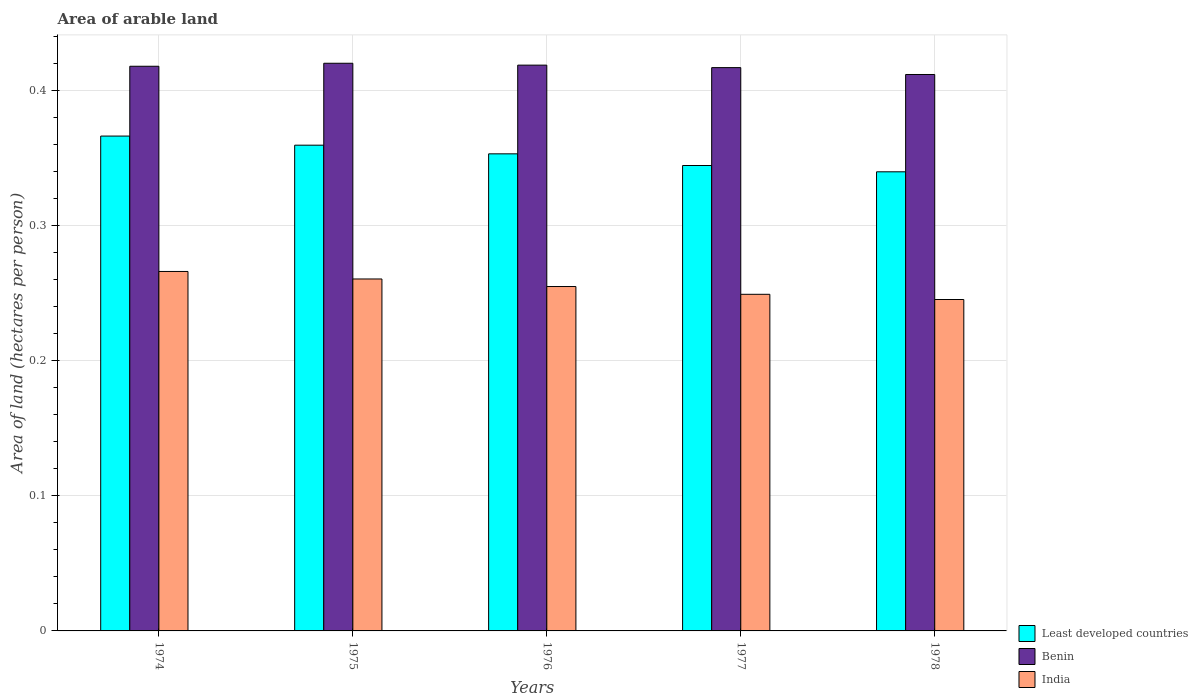How many groups of bars are there?
Make the answer very short. 5. How many bars are there on the 2nd tick from the left?
Give a very brief answer. 3. How many bars are there on the 3rd tick from the right?
Your answer should be compact. 3. What is the label of the 2nd group of bars from the left?
Make the answer very short. 1975. In how many cases, is the number of bars for a given year not equal to the number of legend labels?
Provide a short and direct response. 0. What is the total arable land in Least developed countries in 1974?
Offer a very short reply. 0.37. Across all years, what is the maximum total arable land in India?
Keep it short and to the point. 0.27. Across all years, what is the minimum total arable land in India?
Make the answer very short. 0.25. In which year was the total arable land in Benin maximum?
Keep it short and to the point. 1975. In which year was the total arable land in Least developed countries minimum?
Provide a succinct answer. 1978. What is the total total arable land in India in the graph?
Offer a terse response. 1.28. What is the difference between the total arable land in Benin in 1975 and that in 1976?
Your response must be concise. 0. What is the difference between the total arable land in India in 1975 and the total arable land in Benin in 1976?
Offer a terse response. -0.16. What is the average total arable land in India per year?
Your answer should be compact. 0.26. In the year 1974, what is the difference between the total arable land in India and total arable land in Least developed countries?
Keep it short and to the point. -0.1. In how many years, is the total arable land in India greater than 0.26 hectares per person?
Give a very brief answer. 2. What is the ratio of the total arable land in Benin in 1976 to that in 1977?
Provide a short and direct response. 1. Is the total arable land in Benin in 1974 less than that in 1977?
Keep it short and to the point. No. Is the difference between the total arable land in India in 1974 and 1976 greater than the difference between the total arable land in Least developed countries in 1974 and 1976?
Provide a short and direct response. No. What is the difference between the highest and the second highest total arable land in Benin?
Ensure brevity in your answer.  0. What is the difference between the highest and the lowest total arable land in Least developed countries?
Provide a succinct answer. 0.03. What does the 1st bar from the left in 1975 represents?
Your answer should be very brief. Least developed countries. What does the 2nd bar from the right in 1975 represents?
Offer a very short reply. Benin. Is it the case that in every year, the sum of the total arable land in Least developed countries and total arable land in Benin is greater than the total arable land in India?
Offer a terse response. Yes. How many bars are there?
Offer a terse response. 15. Are all the bars in the graph horizontal?
Your answer should be very brief. No. How many years are there in the graph?
Provide a short and direct response. 5. Does the graph contain any zero values?
Offer a terse response. No. Where does the legend appear in the graph?
Your answer should be compact. Bottom right. How many legend labels are there?
Your answer should be very brief. 3. How are the legend labels stacked?
Your answer should be compact. Vertical. What is the title of the graph?
Ensure brevity in your answer.  Area of arable land. What is the label or title of the X-axis?
Offer a terse response. Years. What is the label or title of the Y-axis?
Your response must be concise. Area of land (hectares per person). What is the Area of land (hectares per person) in Least developed countries in 1974?
Make the answer very short. 0.37. What is the Area of land (hectares per person) of Benin in 1974?
Offer a very short reply. 0.42. What is the Area of land (hectares per person) of India in 1974?
Ensure brevity in your answer.  0.27. What is the Area of land (hectares per person) in Least developed countries in 1975?
Give a very brief answer. 0.36. What is the Area of land (hectares per person) in Benin in 1975?
Provide a short and direct response. 0.42. What is the Area of land (hectares per person) of India in 1975?
Your answer should be compact. 0.26. What is the Area of land (hectares per person) of Least developed countries in 1976?
Make the answer very short. 0.35. What is the Area of land (hectares per person) in Benin in 1976?
Offer a very short reply. 0.42. What is the Area of land (hectares per person) in India in 1976?
Provide a succinct answer. 0.25. What is the Area of land (hectares per person) of Least developed countries in 1977?
Your answer should be compact. 0.34. What is the Area of land (hectares per person) in Benin in 1977?
Your answer should be very brief. 0.42. What is the Area of land (hectares per person) in India in 1977?
Give a very brief answer. 0.25. What is the Area of land (hectares per person) in Least developed countries in 1978?
Provide a succinct answer. 0.34. What is the Area of land (hectares per person) of Benin in 1978?
Provide a succinct answer. 0.41. What is the Area of land (hectares per person) in India in 1978?
Ensure brevity in your answer.  0.25. Across all years, what is the maximum Area of land (hectares per person) of Least developed countries?
Give a very brief answer. 0.37. Across all years, what is the maximum Area of land (hectares per person) of Benin?
Offer a very short reply. 0.42. Across all years, what is the maximum Area of land (hectares per person) of India?
Provide a short and direct response. 0.27. Across all years, what is the minimum Area of land (hectares per person) of Least developed countries?
Your answer should be very brief. 0.34. Across all years, what is the minimum Area of land (hectares per person) of Benin?
Offer a very short reply. 0.41. Across all years, what is the minimum Area of land (hectares per person) of India?
Keep it short and to the point. 0.25. What is the total Area of land (hectares per person) of Least developed countries in the graph?
Your answer should be compact. 1.76. What is the total Area of land (hectares per person) in Benin in the graph?
Offer a terse response. 2.08. What is the total Area of land (hectares per person) in India in the graph?
Provide a succinct answer. 1.27. What is the difference between the Area of land (hectares per person) of Least developed countries in 1974 and that in 1975?
Make the answer very short. 0.01. What is the difference between the Area of land (hectares per person) of Benin in 1974 and that in 1975?
Your answer should be compact. -0. What is the difference between the Area of land (hectares per person) in India in 1974 and that in 1975?
Offer a terse response. 0.01. What is the difference between the Area of land (hectares per person) of Least developed countries in 1974 and that in 1976?
Make the answer very short. 0.01. What is the difference between the Area of land (hectares per person) in Benin in 1974 and that in 1976?
Offer a terse response. -0. What is the difference between the Area of land (hectares per person) of India in 1974 and that in 1976?
Provide a short and direct response. 0.01. What is the difference between the Area of land (hectares per person) in Least developed countries in 1974 and that in 1977?
Ensure brevity in your answer.  0.02. What is the difference between the Area of land (hectares per person) of Benin in 1974 and that in 1977?
Your response must be concise. 0. What is the difference between the Area of land (hectares per person) in India in 1974 and that in 1977?
Keep it short and to the point. 0.02. What is the difference between the Area of land (hectares per person) in Least developed countries in 1974 and that in 1978?
Your answer should be very brief. 0.03. What is the difference between the Area of land (hectares per person) in Benin in 1974 and that in 1978?
Your answer should be compact. 0.01. What is the difference between the Area of land (hectares per person) in India in 1974 and that in 1978?
Offer a very short reply. 0.02. What is the difference between the Area of land (hectares per person) in Least developed countries in 1975 and that in 1976?
Ensure brevity in your answer.  0.01. What is the difference between the Area of land (hectares per person) of Benin in 1975 and that in 1976?
Provide a short and direct response. 0. What is the difference between the Area of land (hectares per person) of India in 1975 and that in 1976?
Your response must be concise. 0.01. What is the difference between the Area of land (hectares per person) of Least developed countries in 1975 and that in 1977?
Provide a succinct answer. 0.01. What is the difference between the Area of land (hectares per person) in Benin in 1975 and that in 1977?
Provide a succinct answer. 0. What is the difference between the Area of land (hectares per person) of India in 1975 and that in 1977?
Offer a terse response. 0.01. What is the difference between the Area of land (hectares per person) in Least developed countries in 1975 and that in 1978?
Your answer should be very brief. 0.02. What is the difference between the Area of land (hectares per person) of Benin in 1975 and that in 1978?
Offer a terse response. 0.01. What is the difference between the Area of land (hectares per person) of India in 1975 and that in 1978?
Provide a short and direct response. 0.02. What is the difference between the Area of land (hectares per person) of Least developed countries in 1976 and that in 1977?
Your answer should be very brief. 0.01. What is the difference between the Area of land (hectares per person) in Benin in 1976 and that in 1977?
Your response must be concise. 0. What is the difference between the Area of land (hectares per person) in India in 1976 and that in 1977?
Your answer should be compact. 0.01. What is the difference between the Area of land (hectares per person) in Least developed countries in 1976 and that in 1978?
Provide a succinct answer. 0.01. What is the difference between the Area of land (hectares per person) in Benin in 1976 and that in 1978?
Keep it short and to the point. 0.01. What is the difference between the Area of land (hectares per person) of India in 1976 and that in 1978?
Make the answer very short. 0.01. What is the difference between the Area of land (hectares per person) of Least developed countries in 1977 and that in 1978?
Keep it short and to the point. 0. What is the difference between the Area of land (hectares per person) of Benin in 1977 and that in 1978?
Make the answer very short. 0.01. What is the difference between the Area of land (hectares per person) in India in 1977 and that in 1978?
Provide a succinct answer. 0. What is the difference between the Area of land (hectares per person) of Least developed countries in 1974 and the Area of land (hectares per person) of Benin in 1975?
Keep it short and to the point. -0.05. What is the difference between the Area of land (hectares per person) of Least developed countries in 1974 and the Area of land (hectares per person) of India in 1975?
Ensure brevity in your answer.  0.11. What is the difference between the Area of land (hectares per person) of Benin in 1974 and the Area of land (hectares per person) of India in 1975?
Your answer should be compact. 0.16. What is the difference between the Area of land (hectares per person) in Least developed countries in 1974 and the Area of land (hectares per person) in Benin in 1976?
Offer a terse response. -0.05. What is the difference between the Area of land (hectares per person) in Least developed countries in 1974 and the Area of land (hectares per person) in India in 1976?
Your answer should be very brief. 0.11. What is the difference between the Area of land (hectares per person) of Benin in 1974 and the Area of land (hectares per person) of India in 1976?
Offer a terse response. 0.16. What is the difference between the Area of land (hectares per person) of Least developed countries in 1974 and the Area of land (hectares per person) of Benin in 1977?
Ensure brevity in your answer.  -0.05. What is the difference between the Area of land (hectares per person) in Least developed countries in 1974 and the Area of land (hectares per person) in India in 1977?
Your answer should be very brief. 0.12. What is the difference between the Area of land (hectares per person) in Benin in 1974 and the Area of land (hectares per person) in India in 1977?
Ensure brevity in your answer.  0.17. What is the difference between the Area of land (hectares per person) in Least developed countries in 1974 and the Area of land (hectares per person) in Benin in 1978?
Provide a succinct answer. -0.05. What is the difference between the Area of land (hectares per person) of Least developed countries in 1974 and the Area of land (hectares per person) of India in 1978?
Give a very brief answer. 0.12. What is the difference between the Area of land (hectares per person) of Benin in 1974 and the Area of land (hectares per person) of India in 1978?
Make the answer very short. 0.17. What is the difference between the Area of land (hectares per person) of Least developed countries in 1975 and the Area of land (hectares per person) of Benin in 1976?
Your answer should be compact. -0.06. What is the difference between the Area of land (hectares per person) in Least developed countries in 1975 and the Area of land (hectares per person) in India in 1976?
Provide a succinct answer. 0.1. What is the difference between the Area of land (hectares per person) in Benin in 1975 and the Area of land (hectares per person) in India in 1976?
Your response must be concise. 0.17. What is the difference between the Area of land (hectares per person) in Least developed countries in 1975 and the Area of land (hectares per person) in Benin in 1977?
Your answer should be compact. -0.06. What is the difference between the Area of land (hectares per person) of Least developed countries in 1975 and the Area of land (hectares per person) of India in 1977?
Keep it short and to the point. 0.11. What is the difference between the Area of land (hectares per person) of Benin in 1975 and the Area of land (hectares per person) of India in 1977?
Provide a succinct answer. 0.17. What is the difference between the Area of land (hectares per person) in Least developed countries in 1975 and the Area of land (hectares per person) in Benin in 1978?
Ensure brevity in your answer.  -0.05. What is the difference between the Area of land (hectares per person) of Least developed countries in 1975 and the Area of land (hectares per person) of India in 1978?
Your response must be concise. 0.11. What is the difference between the Area of land (hectares per person) in Benin in 1975 and the Area of land (hectares per person) in India in 1978?
Offer a very short reply. 0.17. What is the difference between the Area of land (hectares per person) of Least developed countries in 1976 and the Area of land (hectares per person) of Benin in 1977?
Your answer should be compact. -0.06. What is the difference between the Area of land (hectares per person) of Least developed countries in 1976 and the Area of land (hectares per person) of India in 1977?
Offer a terse response. 0.1. What is the difference between the Area of land (hectares per person) in Benin in 1976 and the Area of land (hectares per person) in India in 1977?
Provide a short and direct response. 0.17. What is the difference between the Area of land (hectares per person) of Least developed countries in 1976 and the Area of land (hectares per person) of Benin in 1978?
Give a very brief answer. -0.06. What is the difference between the Area of land (hectares per person) of Least developed countries in 1976 and the Area of land (hectares per person) of India in 1978?
Offer a terse response. 0.11. What is the difference between the Area of land (hectares per person) of Benin in 1976 and the Area of land (hectares per person) of India in 1978?
Ensure brevity in your answer.  0.17. What is the difference between the Area of land (hectares per person) of Least developed countries in 1977 and the Area of land (hectares per person) of Benin in 1978?
Make the answer very short. -0.07. What is the difference between the Area of land (hectares per person) of Least developed countries in 1977 and the Area of land (hectares per person) of India in 1978?
Your answer should be compact. 0.1. What is the difference between the Area of land (hectares per person) in Benin in 1977 and the Area of land (hectares per person) in India in 1978?
Your response must be concise. 0.17. What is the average Area of land (hectares per person) of Least developed countries per year?
Provide a succinct answer. 0.35. What is the average Area of land (hectares per person) of Benin per year?
Make the answer very short. 0.42. What is the average Area of land (hectares per person) in India per year?
Your answer should be compact. 0.26. In the year 1974, what is the difference between the Area of land (hectares per person) of Least developed countries and Area of land (hectares per person) of Benin?
Your answer should be compact. -0.05. In the year 1974, what is the difference between the Area of land (hectares per person) of Least developed countries and Area of land (hectares per person) of India?
Provide a succinct answer. 0.1. In the year 1974, what is the difference between the Area of land (hectares per person) in Benin and Area of land (hectares per person) in India?
Your answer should be compact. 0.15. In the year 1975, what is the difference between the Area of land (hectares per person) in Least developed countries and Area of land (hectares per person) in Benin?
Your answer should be compact. -0.06. In the year 1975, what is the difference between the Area of land (hectares per person) of Least developed countries and Area of land (hectares per person) of India?
Provide a short and direct response. 0.1. In the year 1975, what is the difference between the Area of land (hectares per person) in Benin and Area of land (hectares per person) in India?
Give a very brief answer. 0.16. In the year 1976, what is the difference between the Area of land (hectares per person) in Least developed countries and Area of land (hectares per person) in Benin?
Make the answer very short. -0.07. In the year 1976, what is the difference between the Area of land (hectares per person) in Least developed countries and Area of land (hectares per person) in India?
Provide a succinct answer. 0.1. In the year 1976, what is the difference between the Area of land (hectares per person) of Benin and Area of land (hectares per person) of India?
Your response must be concise. 0.16. In the year 1977, what is the difference between the Area of land (hectares per person) of Least developed countries and Area of land (hectares per person) of Benin?
Your answer should be very brief. -0.07. In the year 1977, what is the difference between the Area of land (hectares per person) in Least developed countries and Area of land (hectares per person) in India?
Your response must be concise. 0.1. In the year 1977, what is the difference between the Area of land (hectares per person) of Benin and Area of land (hectares per person) of India?
Your response must be concise. 0.17. In the year 1978, what is the difference between the Area of land (hectares per person) in Least developed countries and Area of land (hectares per person) in Benin?
Your answer should be compact. -0.07. In the year 1978, what is the difference between the Area of land (hectares per person) of Least developed countries and Area of land (hectares per person) of India?
Give a very brief answer. 0.09. In the year 1978, what is the difference between the Area of land (hectares per person) in Benin and Area of land (hectares per person) in India?
Give a very brief answer. 0.17. What is the ratio of the Area of land (hectares per person) of Least developed countries in 1974 to that in 1975?
Offer a very short reply. 1.02. What is the ratio of the Area of land (hectares per person) of India in 1974 to that in 1975?
Offer a very short reply. 1.02. What is the ratio of the Area of land (hectares per person) in Least developed countries in 1974 to that in 1976?
Provide a short and direct response. 1.04. What is the ratio of the Area of land (hectares per person) of Benin in 1974 to that in 1976?
Your response must be concise. 1. What is the ratio of the Area of land (hectares per person) of India in 1974 to that in 1976?
Your response must be concise. 1.04. What is the ratio of the Area of land (hectares per person) of Least developed countries in 1974 to that in 1977?
Make the answer very short. 1.06. What is the ratio of the Area of land (hectares per person) in Benin in 1974 to that in 1977?
Provide a succinct answer. 1. What is the ratio of the Area of land (hectares per person) in India in 1974 to that in 1977?
Give a very brief answer. 1.07. What is the ratio of the Area of land (hectares per person) of Least developed countries in 1974 to that in 1978?
Make the answer very short. 1.08. What is the ratio of the Area of land (hectares per person) in Benin in 1974 to that in 1978?
Your answer should be very brief. 1.01. What is the ratio of the Area of land (hectares per person) of India in 1974 to that in 1978?
Give a very brief answer. 1.08. What is the ratio of the Area of land (hectares per person) in Least developed countries in 1975 to that in 1976?
Offer a very short reply. 1.02. What is the ratio of the Area of land (hectares per person) of India in 1975 to that in 1976?
Offer a terse response. 1.02. What is the ratio of the Area of land (hectares per person) of Least developed countries in 1975 to that in 1977?
Your answer should be very brief. 1.04. What is the ratio of the Area of land (hectares per person) in Benin in 1975 to that in 1977?
Provide a succinct answer. 1.01. What is the ratio of the Area of land (hectares per person) in India in 1975 to that in 1977?
Keep it short and to the point. 1.05. What is the ratio of the Area of land (hectares per person) in Least developed countries in 1975 to that in 1978?
Offer a very short reply. 1.06. What is the ratio of the Area of land (hectares per person) of Benin in 1975 to that in 1978?
Your answer should be very brief. 1.02. What is the ratio of the Area of land (hectares per person) in India in 1975 to that in 1978?
Your answer should be compact. 1.06. What is the ratio of the Area of land (hectares per person) of Least developed countries in 1976 to that in 1977?
Your answer should be compact. 1.03. What is the ratio of the Area of land (hectares per person) of India in 1976 to that in 1977?
Provide a short and direct response. 1.02. What is the ratio of the Area of land (hectares per person) of Least developed countries in 1976 to that in 1978?
Provide a short and direct response. 1.04. What is the ratio of the Area of land (hectares per person) in Benin in 1976 to that in 1978?
Give a very brief answer. 1.02. What is the ratio of the Area of land (hectares per person) of India in 1976 to that in 1978?
Provide a short and direct response. 1.04. What is the ratio of the Area of land (hectares per person) of Least developed countries in 1977 to that in 1978?
Your answer should be compact. 1.01. What is the ratio of the Area of land (hectares per person) in Benin in 1977 to that in 1978?
Provide a short and direct response. 1.01. What is the ratio of the Area of land (hectares per person) of India in 1977 to that in 1978?
Provide a succinct answer. 1.02. What is the difference between the highest and the second highest Area of land (hectares per person) of Least developed countries?
Your answer should be compact. 0.01. What is the difference between the highest and the second highest Area of land (hectares per person) in Benin?
Ensure brevity in your answer.  0. What is the difference between the highest and the second highest Area of land (hectares per person) in India?
Give a very brief answer. 0.01. What is the difference between the highest and the lowest Area of land (hectares per person) of Least developed countries?
Provide a short and direct response. 0.03. What is the difference between the highest and the lowest Area of land (hectares per person) of Benin?
Give a very brief answer. 0.01. What is the difference between the highest and the lowest Area of land (hectares per person) in India?
Offer a very short reply. 0.02. 